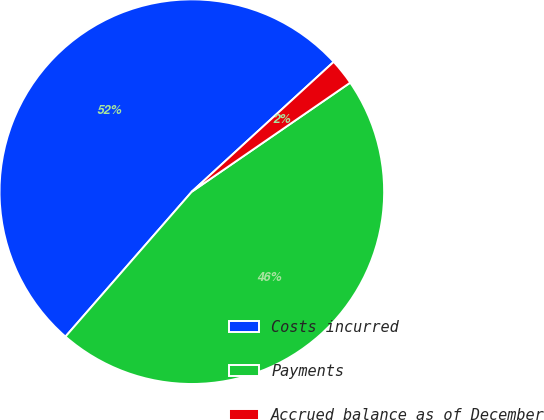Convert chart. <chart><loc_0><loc_0><loc_500><loc_500><pie_chart><fcel>Costs incurred<fcel>Payments<fcel>Accrued balance as of December<nl><fcel>51.79%<fcel>46.01%<fcel>2.2%<nl></chart> 